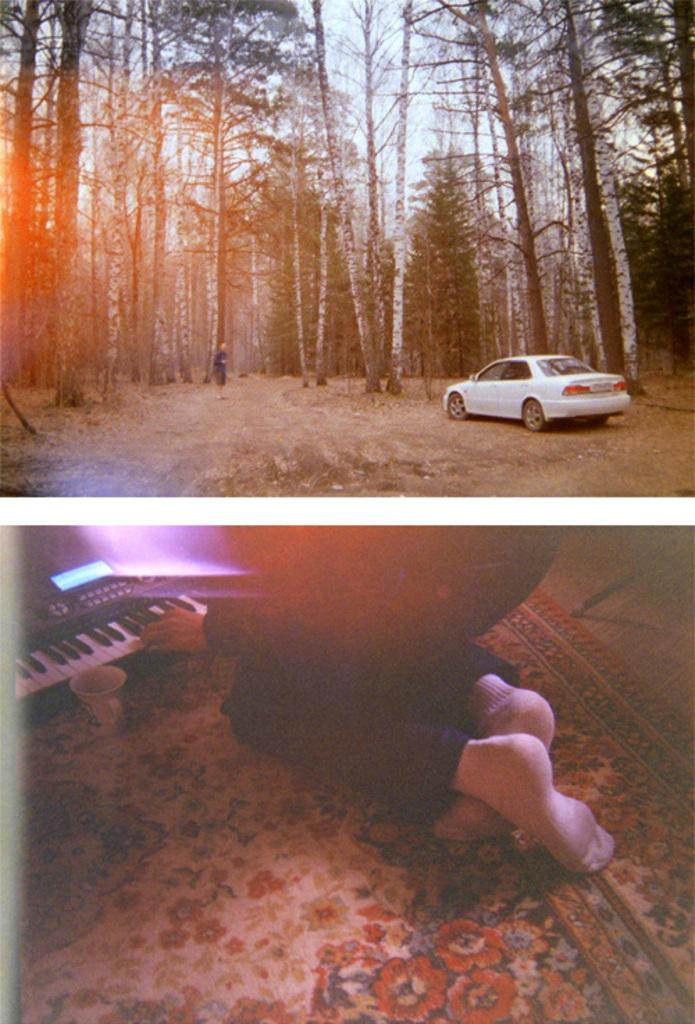How many sections are there in the image? There are two distinct sections in the image. What can be seen in the top section of the image? In the top section, there is a car, trees, and sky. What objects and elements are present in the bottom section of the image? In the bottom section, there is a person, a keyboard, a cup, and a mat. What type of doll is sitting next to the fire in the image? There is no doll or fire present in the image. What is the engine used for in the image? There is no engine present in the image. 